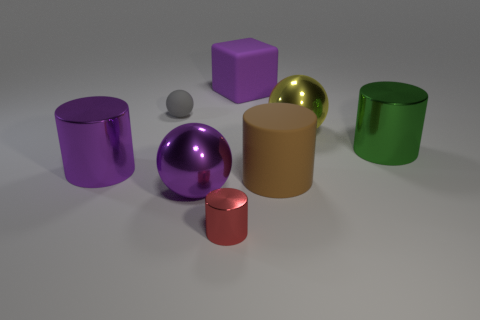Subtract all brown cylinders. How many cylinders are left? 3 Subtract all rubber cylinders. How many cylinders are left? 3 Subtract all blue cylinders. Subtract all brown cubes. How many cylinders are left? 4 Add 2 tiny green rubber balls. How many objects exist? 10 Subtract all blocks. How many objects are left? 7 Add 5 balls. How many balls exist? 8 Subtract 0 brown blocks. How many objects are left? 8 Subtract all big yellow metallic things. Subtract all tiny spheres. How many objects are left? 6 Add 3 green cylinders. How many green cylinders are left? 4 